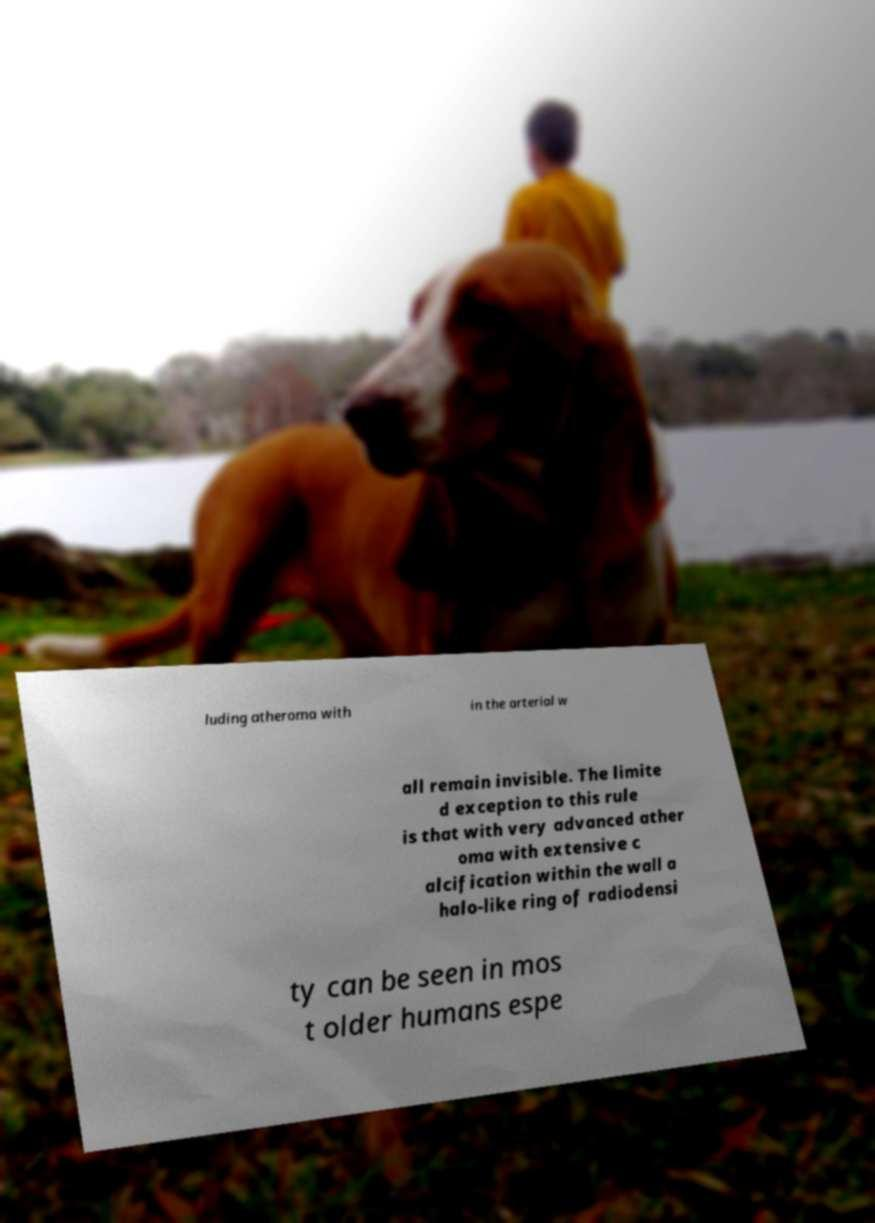Please identify and transcribe the text found in this image. luding atheroma with in the arterial w all remain invisible. The limite d exception to this rule is that with very advanced ather oma with extensive c alcification within the wall a halo-like ring of radiodensi ty can be seen in mos t older humans espe 